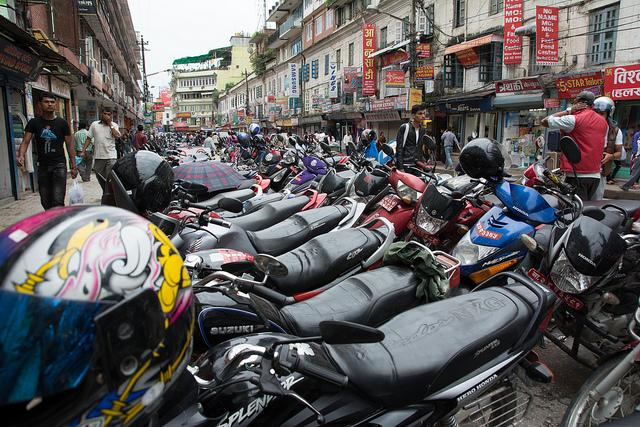The motorbikes on this bustling city street are present in which country? india 